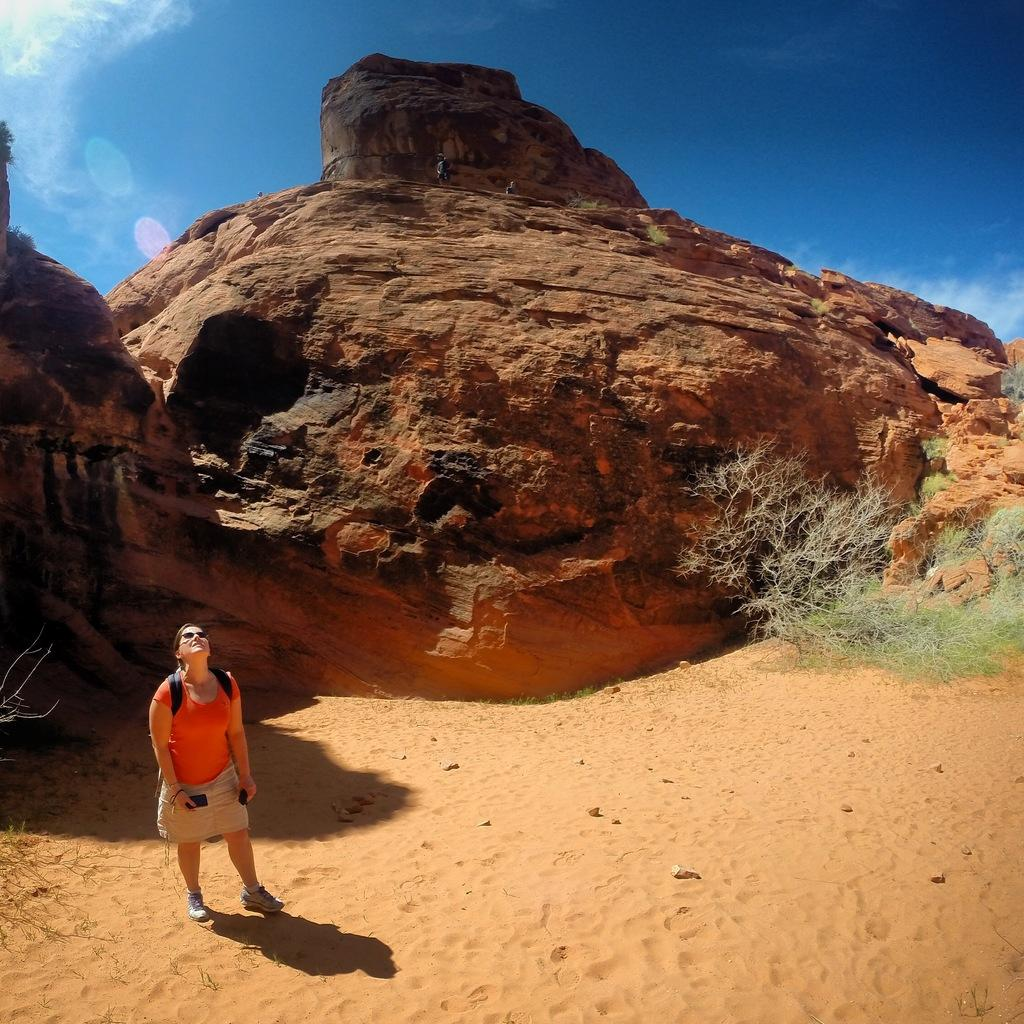What is the woman in the image doing? The woman is standing on the ground and holding a device. What else can be seen in the image besides the woman? There are plants visible in the image, as well as people standing on a hill. How would you describe the sky in the image? The sky is visible in the image and appears cloudy. How much money is the woman holding in the image? There is no indication of money in the image; the woman is holding a device. What type of art can be seen on the hill in the image? There is no art visible on the hill in the image; only people are standing there. 